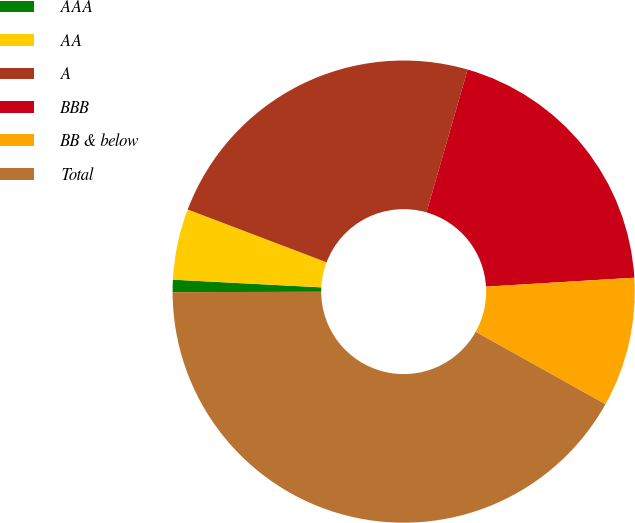Convert chart to OTSL. <chart><loc_0><loc_0><loc_500><loc_500><pie_chart><fcel>AAA<fcel>AA<fcel>A<fcel>BBB<fcel>BB & below<fcel>Total<nl><fcel>0.86%<fcel>4.96%<fcel>23.68%<fcel>19.58%<fcel>9.06%<fcel>41.86%<nl></chart> 